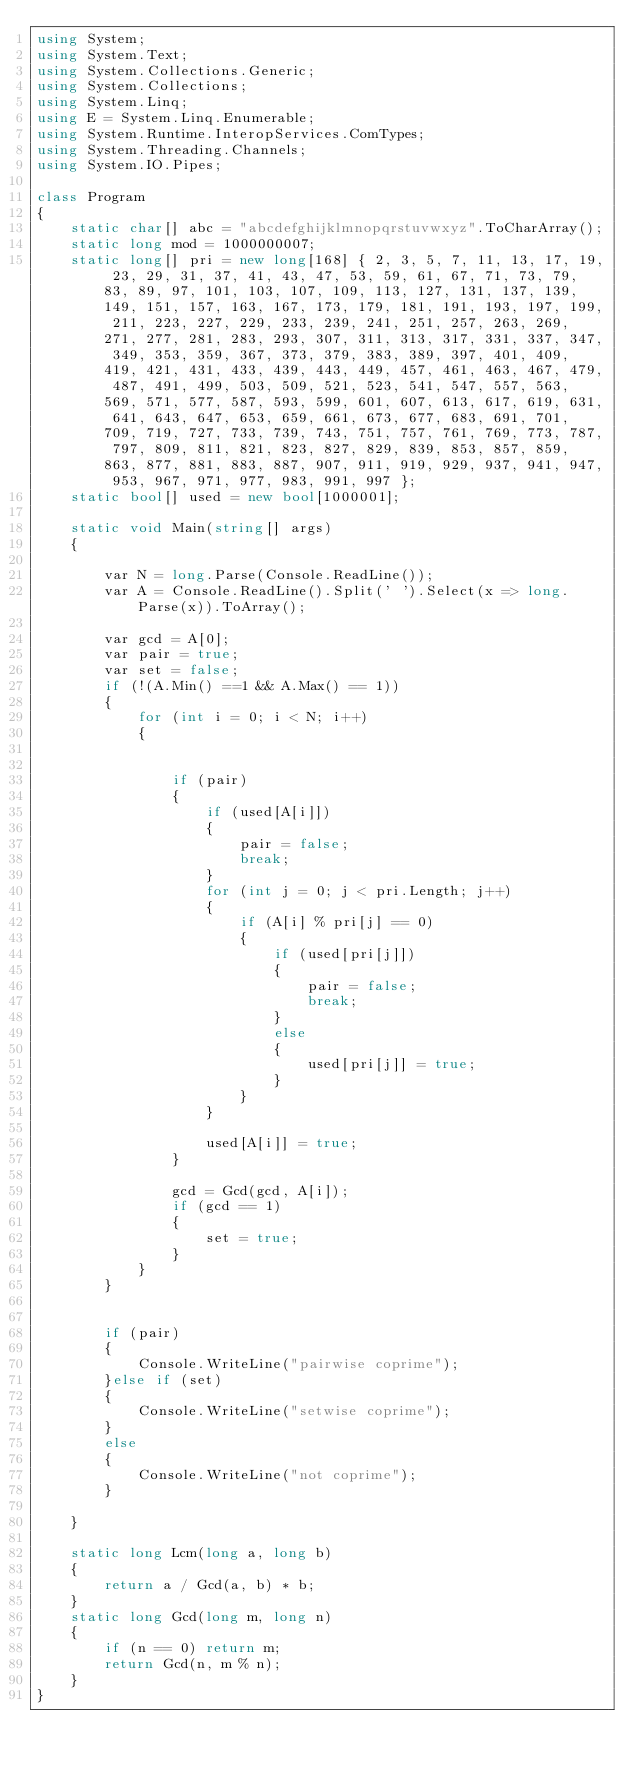<code> <loc_0><loc_0><loc_500><loc_500><_C#_>using System;
using System.Text;
using System.Collections.Generic;
using System.Collections;
using System.Linq;
using E = System.Linq.Enumerable;
using System.Runtime.InteropServices.ComTypes;
using System.Threading.Channels;
using System.IO.Pipes;

class Program
{
    static char[] abc = "abcdefghijklmnopqrstuvwxyz".ToCharArray();
    static long mod = 1000000007;
    static long[] pri = new long[168] { 2, 3, 5, 7, 11, 13, 17, 19, 23, 29, 31, 37, 41, 43, 47, 53, 59, 61, 67, 71, 73, 79, 83, 89, 97, 101, 103, 107, 109, 113, 127, 131, 137, 139, 149, 151, 157, 163, 167, 173, 179, 181, 191, 193, 197, 199, 211, 223, 227, 229, 233, 239, 241, 251, 257, 263, 269, 271, 277, 281, 283, 293, 307, 311, 313, 317, 331, 337, 347, 349, 353, 359, 367, 373, 379, 383, 389, 397, 401, 409, 419, 421, 431, 433, 439, 443, 449, 457, 461, 463, 467, 479, 487, 491, 499, 503, 509, 521, 523, 541, 547, 557, 563, 569, 571, 577, 587, 593, 599, 601, 607, 613, 617, 619, 631, 641, 643, 647, 653, 659, 661, 673, 677, 683, 691, 701, 709, 719, 727, 733, 739, 743, 751, 757, 761, 769, 773, 787, 797, 809, 811, 821, 823, 827, 829, 839, 853, 857, 859, 863, 877, 881, 883, 887, 907, 911, 919, 929, 937, 941, 947, 953, 967, 971, 977, 983, 991, 997 };
    static bool[] used = new bool[1000001];

    static void Main(string[] args)
    {

        var N = long.Parse(Console.ReadLine());
        var A = Console.ReadLine().Split(' ').Select(x => long.Parse(x)).ToArray();

        var gcd = A[0];
        var pair = true;
        var set = false;
        if (!(A.Min() ==1 && A.Max() == 1))
        {
            for (int i = 0; i < N; i++)
            {


                if (pair)
                {
                    if (used[A[i]])
                    {
                        pair = false;
                        break;
                    }
                    for (int j = 0; j < pri.Length; j++)
                    {
                        if (A[i] % pri[j] == 0)
                        {
                            if (used[pri[j]])
                            {
                                pair = false;
                                break;
                            }
                            else
                            {
                                used[pri[j]] = true;
                            }
                        }
                    }

                    used[A[i]] = true;
                }

                gcd = Gcd(gcd, A[i]);
                if (gcd == 1)
                {
                    set = true;
                }
            }
        }
        

        if (pair)
        {
            Console.WriteLine("pairwise coprime");
        }else if (set)
        {
            Console.WriteLine("setwise coprime");
        }
        else
        {
            Console.WriteLine("not coprime");
        }
        
    }

    static long Lcm(long a, long b)
    {
        return a / Gcd(a, b) * b;
    }
    static long Gcd(long m, long n)
    {
        if (n == 0) return m;
        return Gcd(n, m % n);
    }
}


</code> 